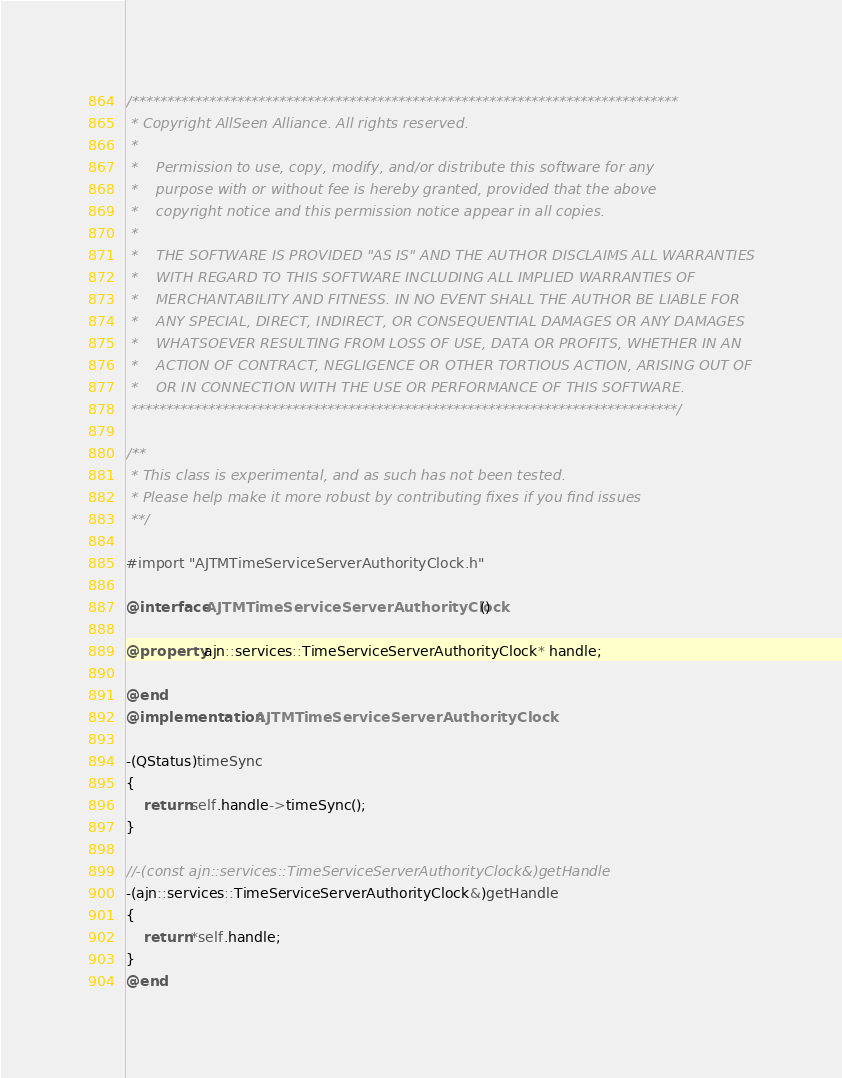Convert code to text. <code><loc_0><loc_0><loc_500><loc_500><_ObjectiveC_>/******************************************************************************
 * Copyright AllSeen Alliance. All rights reserved.
 *
 *    Permission to use, copy, modify, and/or distribute this software for any
 *    purpose with or without fee is hereby granted, provided that the above
 *    copyright notice and this permission notice appear in all copies.
 *
 *    THE SOFTWARE IS PROVIDED "AS IS" AND THE AUTHOR DISCLAIMS ALL WARRANTIES
 *    WITH REGARD TO THIS SOFTWARE INCLUDING ALL IMPLIED WARRANTIES OF
 *    MERCHANTABILITY AND FITNESS. IN NO EVENT SHALL THE AUTHOR BE LIABLE FOR
 *    ANY SPECIAL, DIRECT, INDIRECT, OR CONSEQUENTIAL DAMAGES OR ANY DAMAGES
 *    WHATSOEVER RESULTING FROM LOSS OF USE, DATA OR PROFITS, WHETHER IN AN
 *    ACTION OF CONTRACT, NEGLIGENCE OR OTHER TORTIOUS ACTION, ARISING OUT OF
 *    OR IN CONNECTION WITH THE USE OR PERFORMANCE OF THIS SOFTWARE.
 ******************************************************************************/

/**
 * This class is experimental, and as such has not been tested.
 * Please help make it more robust by contributing fixes if you find issues
 **/

#import "AJTMTimeServiceServerAuthorityClock.h"

@interface AJTMTimeServiceServerAuthorityClock ()

@property ajn::services::TimeServiceServerAuthorityClock* handle;

@end
@implementation AJTMTimeServiceServerAuthorityClock

-(QStatus)timeSync
{
    return self.handle->timeSync();
}

//-(const ajn::services::TimeServiceServerAuthorityClock&)getHandle
-(ajn::services::TimeServiceServerAuthorityClock&)getHandle
{
    return *self.handle;
}
@end
</code> 